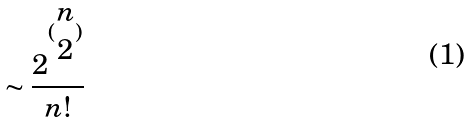<formula> <loc_0><loc_0><loc_500><loc_500>\sim \frac { 2 ^ { ( \begin{matrix} n \\ 2 \end{matrix} ) } } { n ! }</formula> 